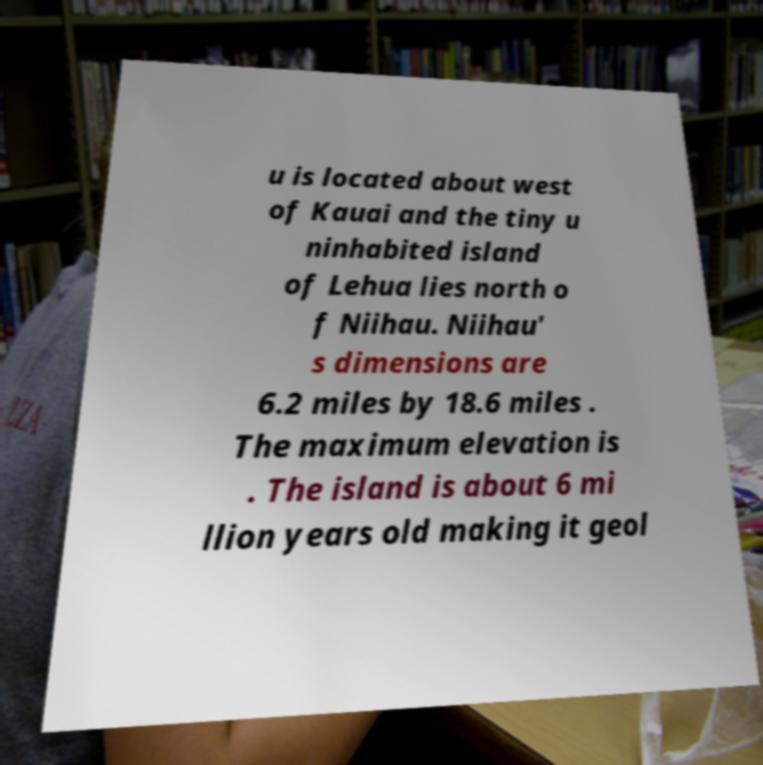Could you extract and type out the text from this image? u is located about west of Kauai and the tiny u ninhabited island of Lehua lies north o f Niihau. Niihau' s dimensions are 6.2 miles by 18.6 miles . The maximum elevation is . The island is about 6 mi llion years old making it geol 